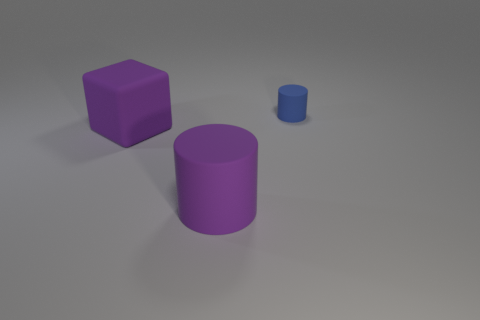Are there any other things that have the same shape as the blue matte object?
Your answer should be compact. Yes. Is there any other thing that has the same material as the large cube?
Make the answer very short. Yes. How big is the purple block?
Your answer should be compact. Large. There is a rubber object that is behind the purple matte cylinder and in front of the small object; what color is it?
Give a very brief answer. Purple. Are there more large purple matte cylinders than tiny gray metallic objects?
Your answer should be very brief. Yes. How many objects are either large brown metal spheres or rubber cylinders left of the small blue cylinder?
Provide a short and direct response. 1. Does the blue cylinder have the same size as the cube?
Make the answer very short. No. Are there any tiny blue matte things behind the tiny cylinder?
Provide a succinct answer. No. There is a thing that is to the right of the big purple cube and left of the tiny blue rubber thing; what is its size?
Offer a terse response. Large. How many things are either cyan balls or blue matte things?
Offer a very short reply. 1. 